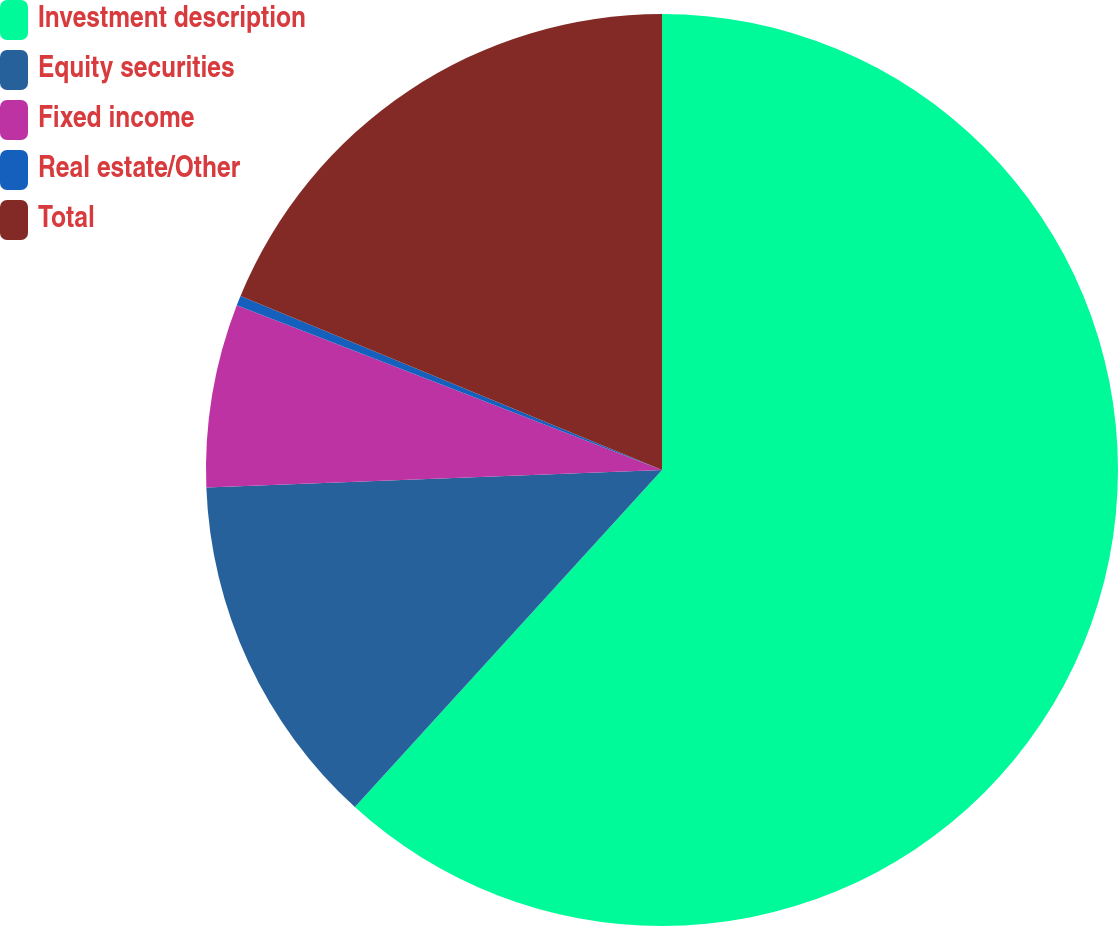Convert chart to OTSL. <chart><loc_0><loc_0><loc_500><loc_500><pie_chart><fcel>Investment description<fcel>Equity securities<fcel>Fixed income<fcel>Real estate/Other<fcel>Total<nl><fcel>61.76%<fcel>12.63%<fcel>6.49%<fcel>0.35%<fcel>18.77%<nl></chart> 